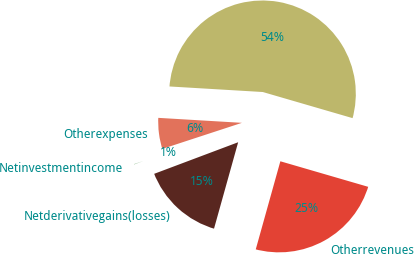Convert chart to OTSL. <chart><loc_0><loc_0><loc_500><loc_500><pie_chart><ecel><fcel>Otherexpenses<fcel>Netinvestmentincome<fcel>Netderivativegains(losses)<fcel>Otherrevenues<nl><fcel>53.56%<fcel>5.98%<fcel>0.69%<fcel>14.94%<fcel>24.83%<nl></chart> 